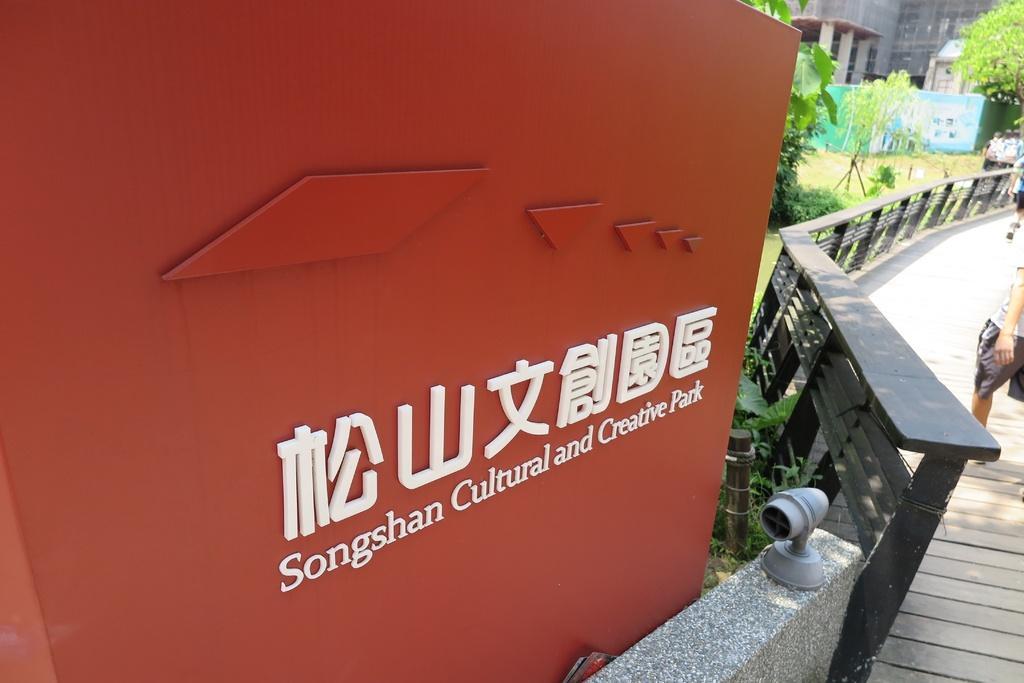Describe this image in one or two sentences. In this picture we can see name board. On the right side of the name board there is a wall and the fence. There are two people walking on the walkway. On the right side of the fence there are trees. At the top right corner of the image there is a building. 